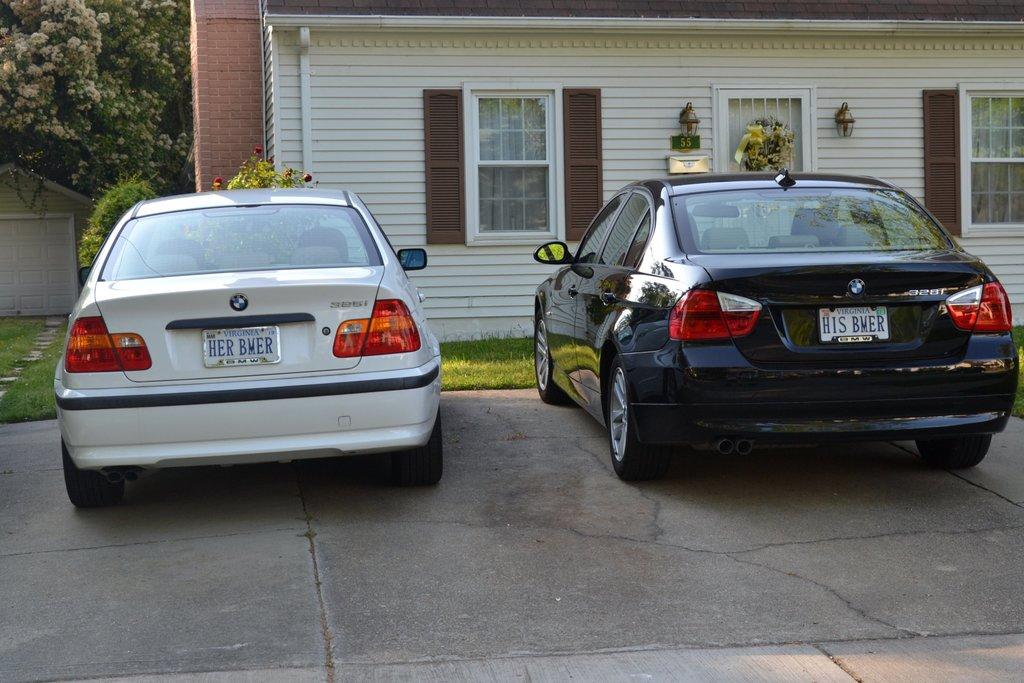Does the same person own both cars?
Provide a succinct answer. Unanswerable. What does the license plate say on the white car?
Make the answer very short. Her bmer. 